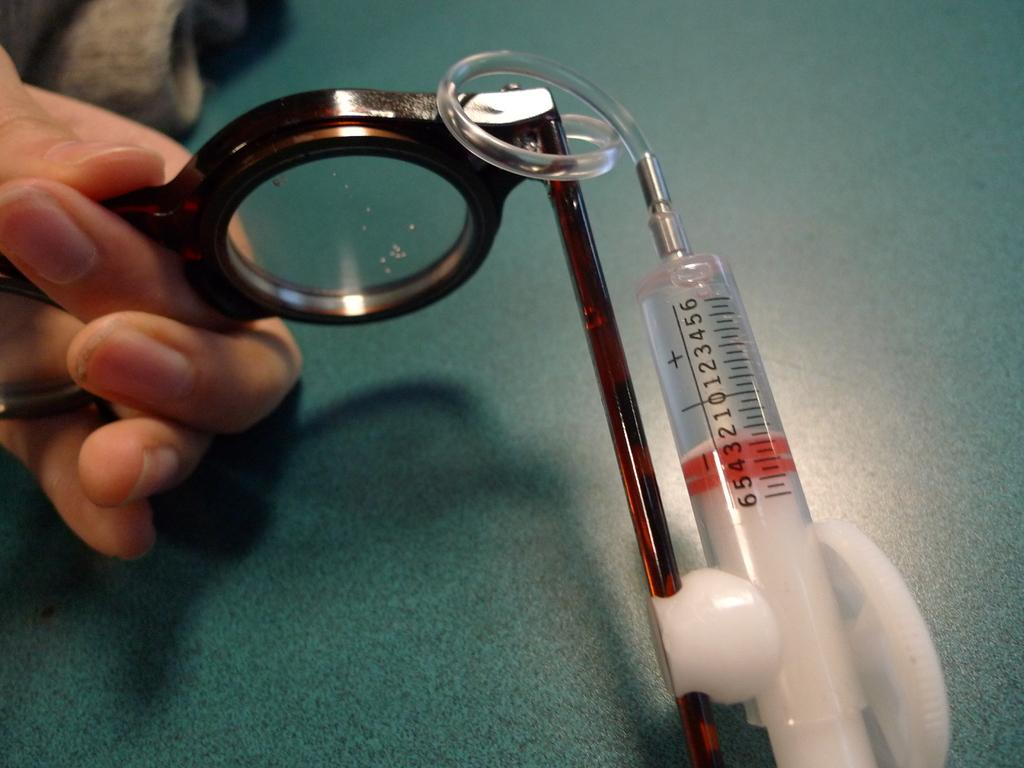<image>
Render a clear and concise summary of the photo. A syringe's red plunger is situated between the 3 and the 5 on the scale on the side. 